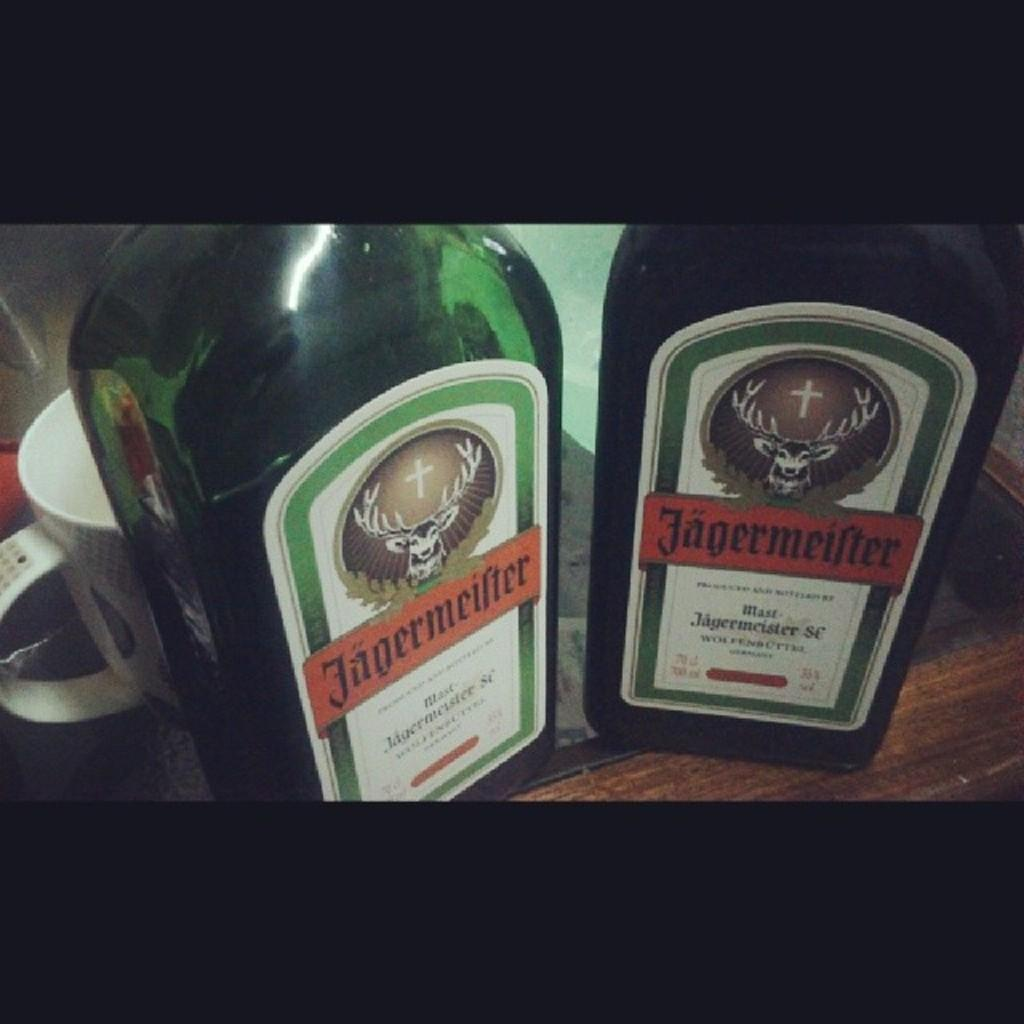<image>
Describe the image concisely. Two bottles of Jagermeister stand side by side on a wooden table with a white mug behind one of them. 